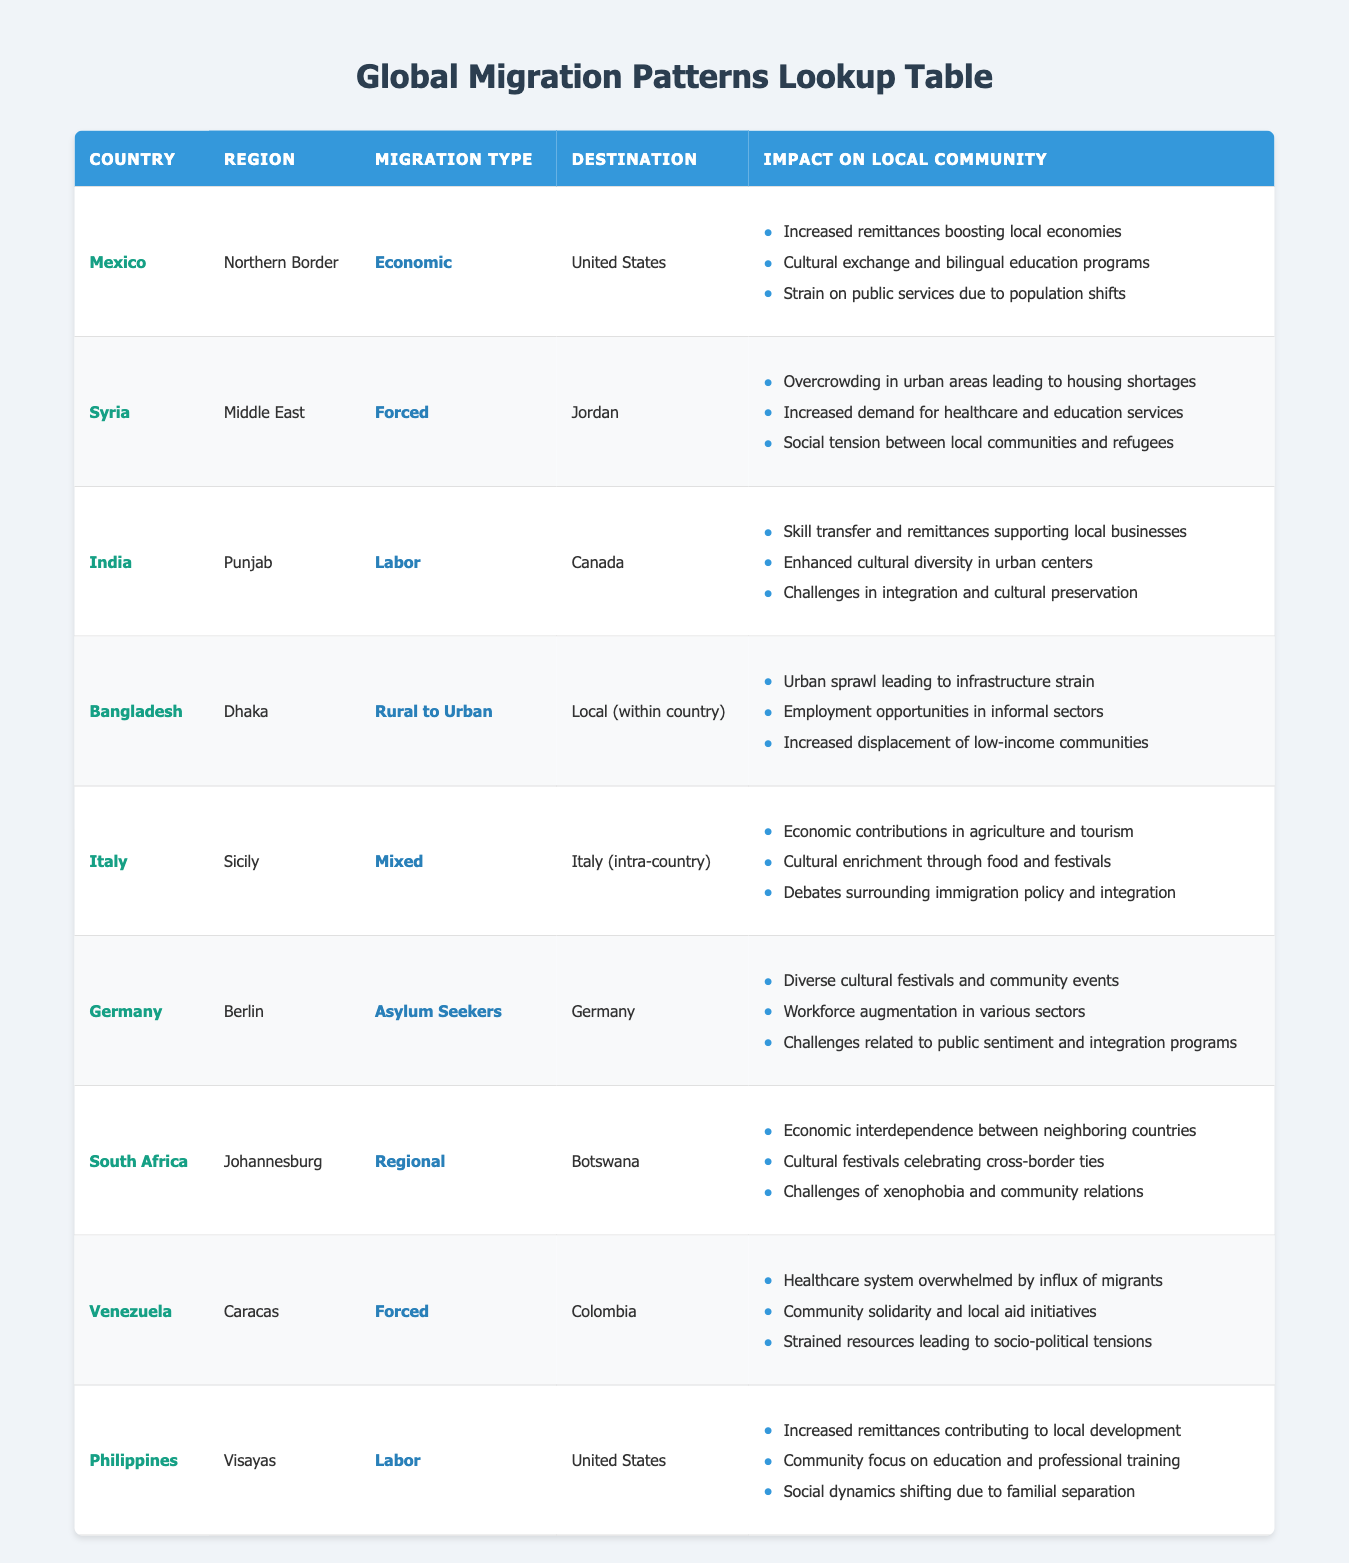What is the migration type for Mexico? According to the table, Mexico is categorized under the "Economic" migration type in the Northern Border region.
Answer: Economic Which country do migrants from Syria predominantly relocate to? From the table, it is shown that migrants from Syria predominantly relocate to Jordan.
Answer: Jordan How many impacts on local communities does Bangladesh's migration pattern have? The table lists three specific impacts for Bangladesh, which include urban sprawl, employment opportunities, and increased displacement.
Answer: 3 Is the impact on local communities in Germany positive? The table indicates that the impacts include diverse cultural festivals, workforce augmentation, but also challenges related to public sentiment; hence, it presents both positive and negative aspects.
Answer: No What is the most common impact on communities affected by forced migration? Analyzing the table, common impacts for forced migration cases include overwhelming healthcare systems and socio-political tensions. Of all the entries, these themes appear consistently.
Answer: Overwhelmed healthcare systems and socio-political tensions What is the sum of the unique regions represented in the table? There are eight unique regions listed for the countries: Northern Border, Middle East, Punjab, Dhaka, Sicily, Berlin, Johannesburg, and Visayas, thus the total count is 8.
Answer: 8 Do cultural exchanges occur due to migration from Mexico? The table clearly states that cultural exchanges and bilingual education programs are indeed impacts of migration from Mexico, confirming the affirmative.
Answer: Yes What challenges are faced concerning labor migration from India to Canada? The table details that challenges include integration issues and cultural preservation, alongside the benefits seen in skills transfer and cultural diversity. Thus, there are specific challenges presented.
Answer: Integration and cultural preservation challenges What type of migration is predominant in the Philippines? The table specifies that the predominant type of migration in the Philippines is "Labor," indicating its primary nature, especially towards the United States.
Answer: Labor 